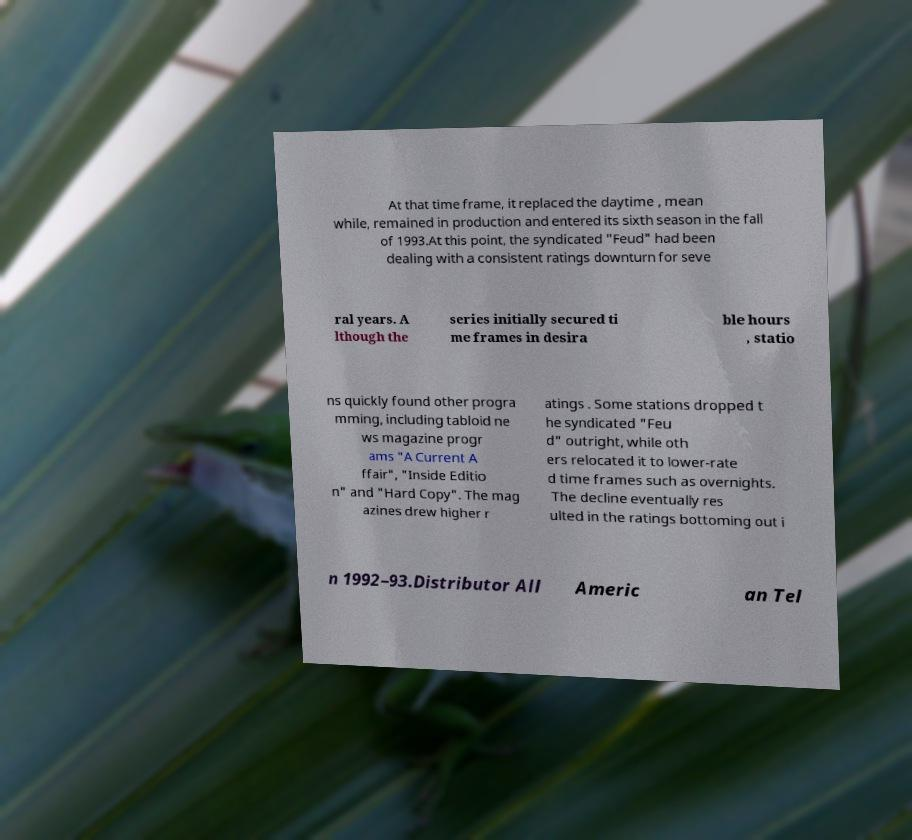I need the written content from this picture converted into text. Can you do that? At that time frame, it replaced the daytime , mean while, remained in production and entered its sixth season in the fall of 1993.At this point, the syndicated "Feud" had been dealing with a consistent ratings downturn for seve ral years. A lthough the series initially secured ti me frames in desira ble hours , statio ns quickly found other progra mming, including tabloid ne ws magazine progr ams "A Current A ffair", "Inside Editio n" and "Hard Copy". The mag azines drew higher r atings . Some stations dropped t he syndicated "Feu d" outright, while oth ers relocated it to lower-rate d time frames such as overnights. The decline eventually res ulted in the ratings bottoming out i n 1992–93.Distributor All Americ an Tel 